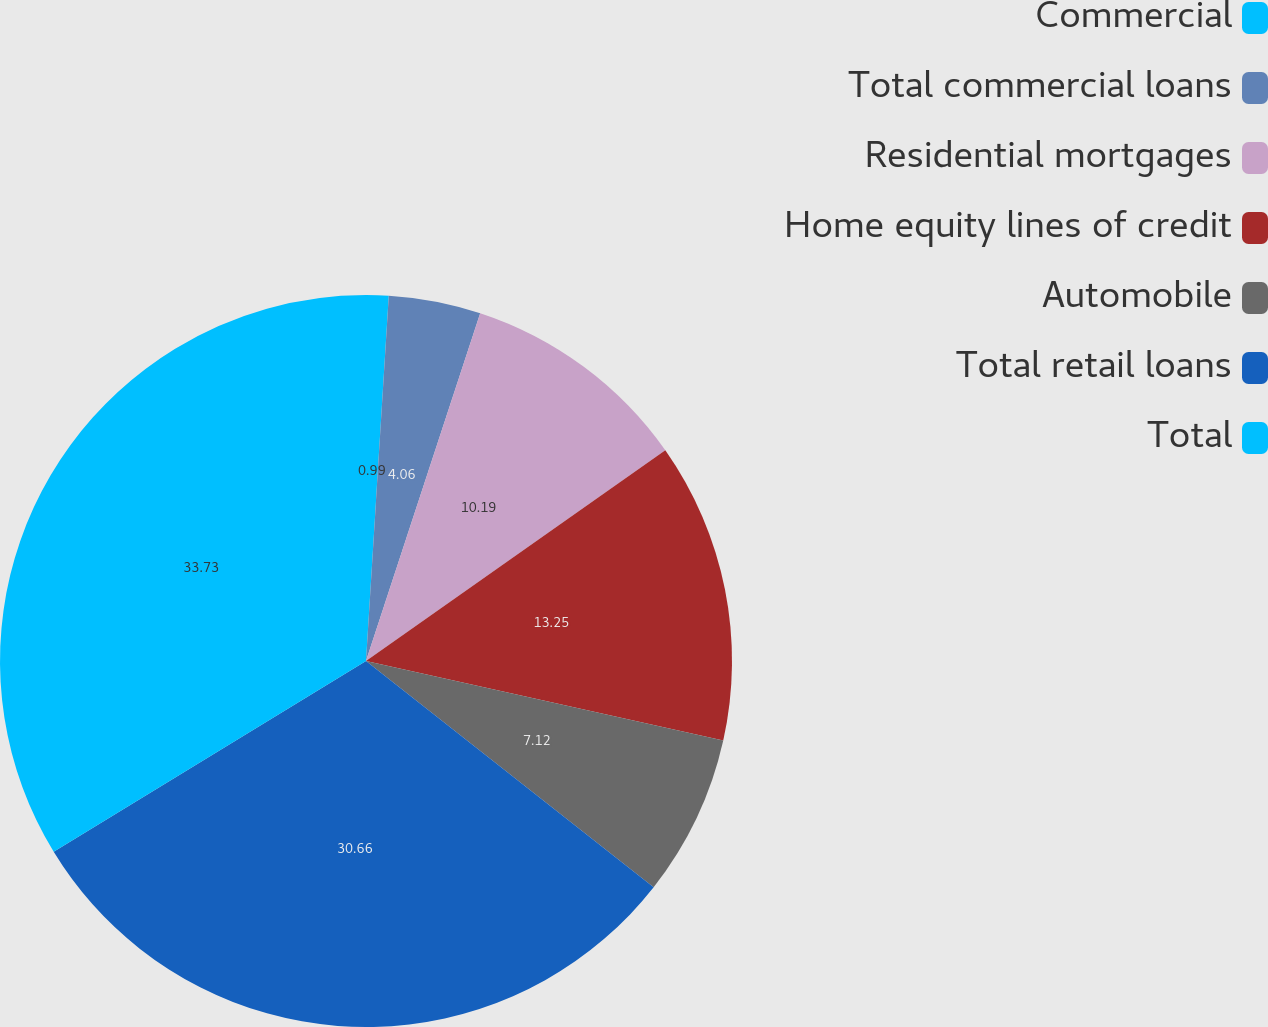Convert chart to OTSL. <chart><loc_0><loc_0><loc_500><loc_500><pie_chart><fcel>Commercial<fcel>Total commercial loans<fcel>Residential mortgages<fcel>Home equity lines of credit<fcel>Automobile<fcel>Total retail loans<fcel>Total<nl><fcel>0.99%<fcel>4.06%<fcel>10.19%<fcel>13.25%<fcel>7.12%<fcel>30.66%<fcel>33.73%<nl></chart> 